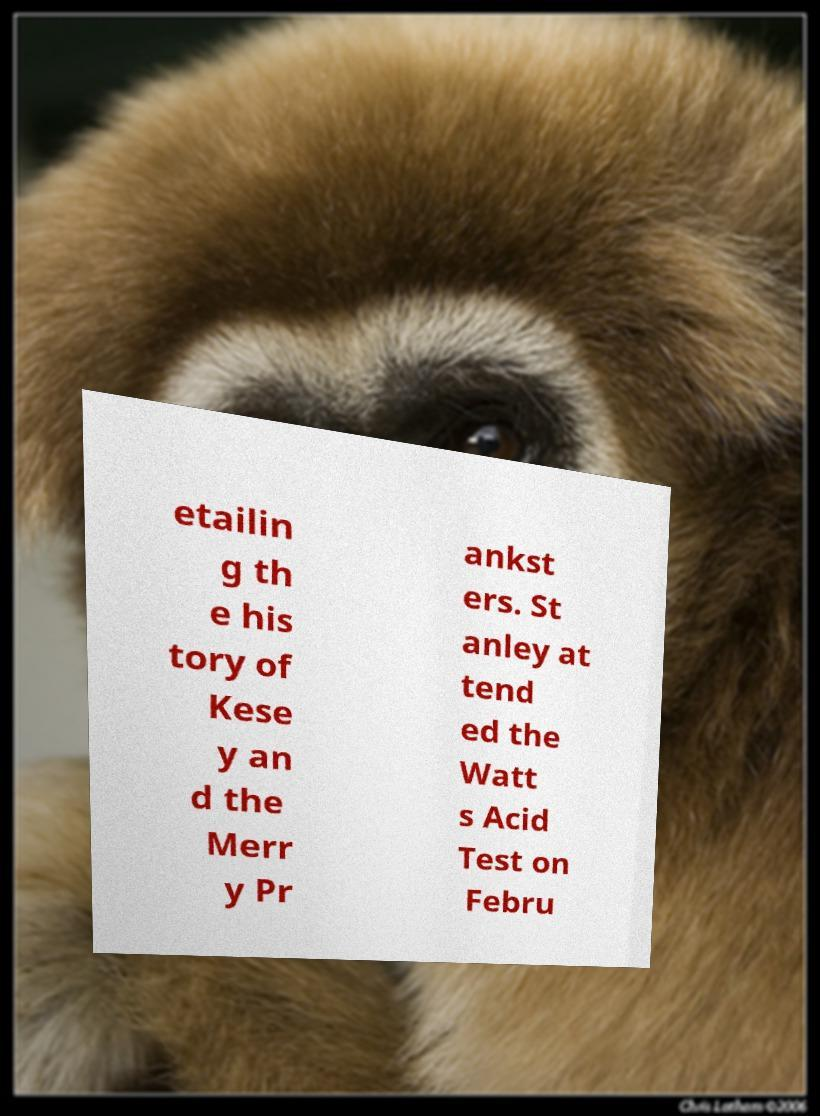I need the written content from this picture converted into text. Can you do that? etailin g th e his tory of Kese y an d the Merr y Pr ankst ers. St anley at tend ed the Watt s Acid Test on Febru 